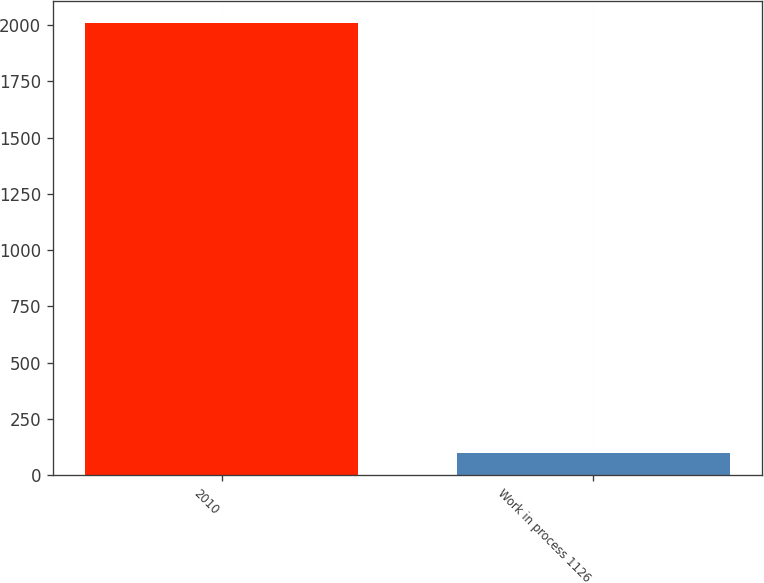<chart> <loc_0><loc_0><loc_500><loc_500><bar_chart><fcel>2010<fcel>Work in process 1126<nl><fcel>2009<fcel>97.2<nl></chart> 